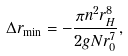<formula> <loc_0><loc_0><loc_500><loc_500>\Delta r _ { \min } = - \frac { \pi n ^ { 2 } r _ { H } ^ { 8 } } { 2 g N r _ { 0 } ^ { 7 } } ,</formula> 